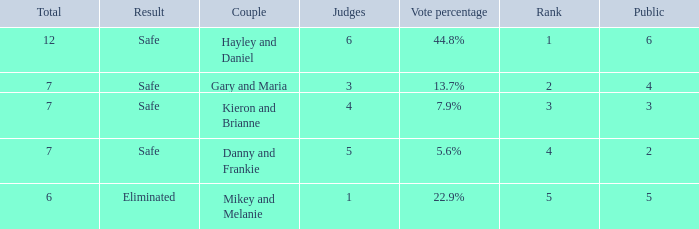How many public is there for the couple that got eliminated? 5.0. 